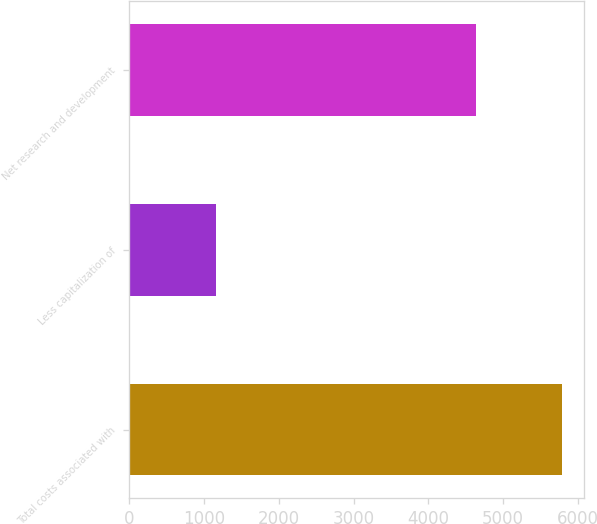Convert chart to OTSL. <chart><loc_0><loc_0><loc_500><loc_500><bar_chart><fcel>Total costs associated with<fcel>Less capitalization of<fcel>Net research and development<nl><fcel>5790<fcel>1156<fcel>4634<nl></chart> 